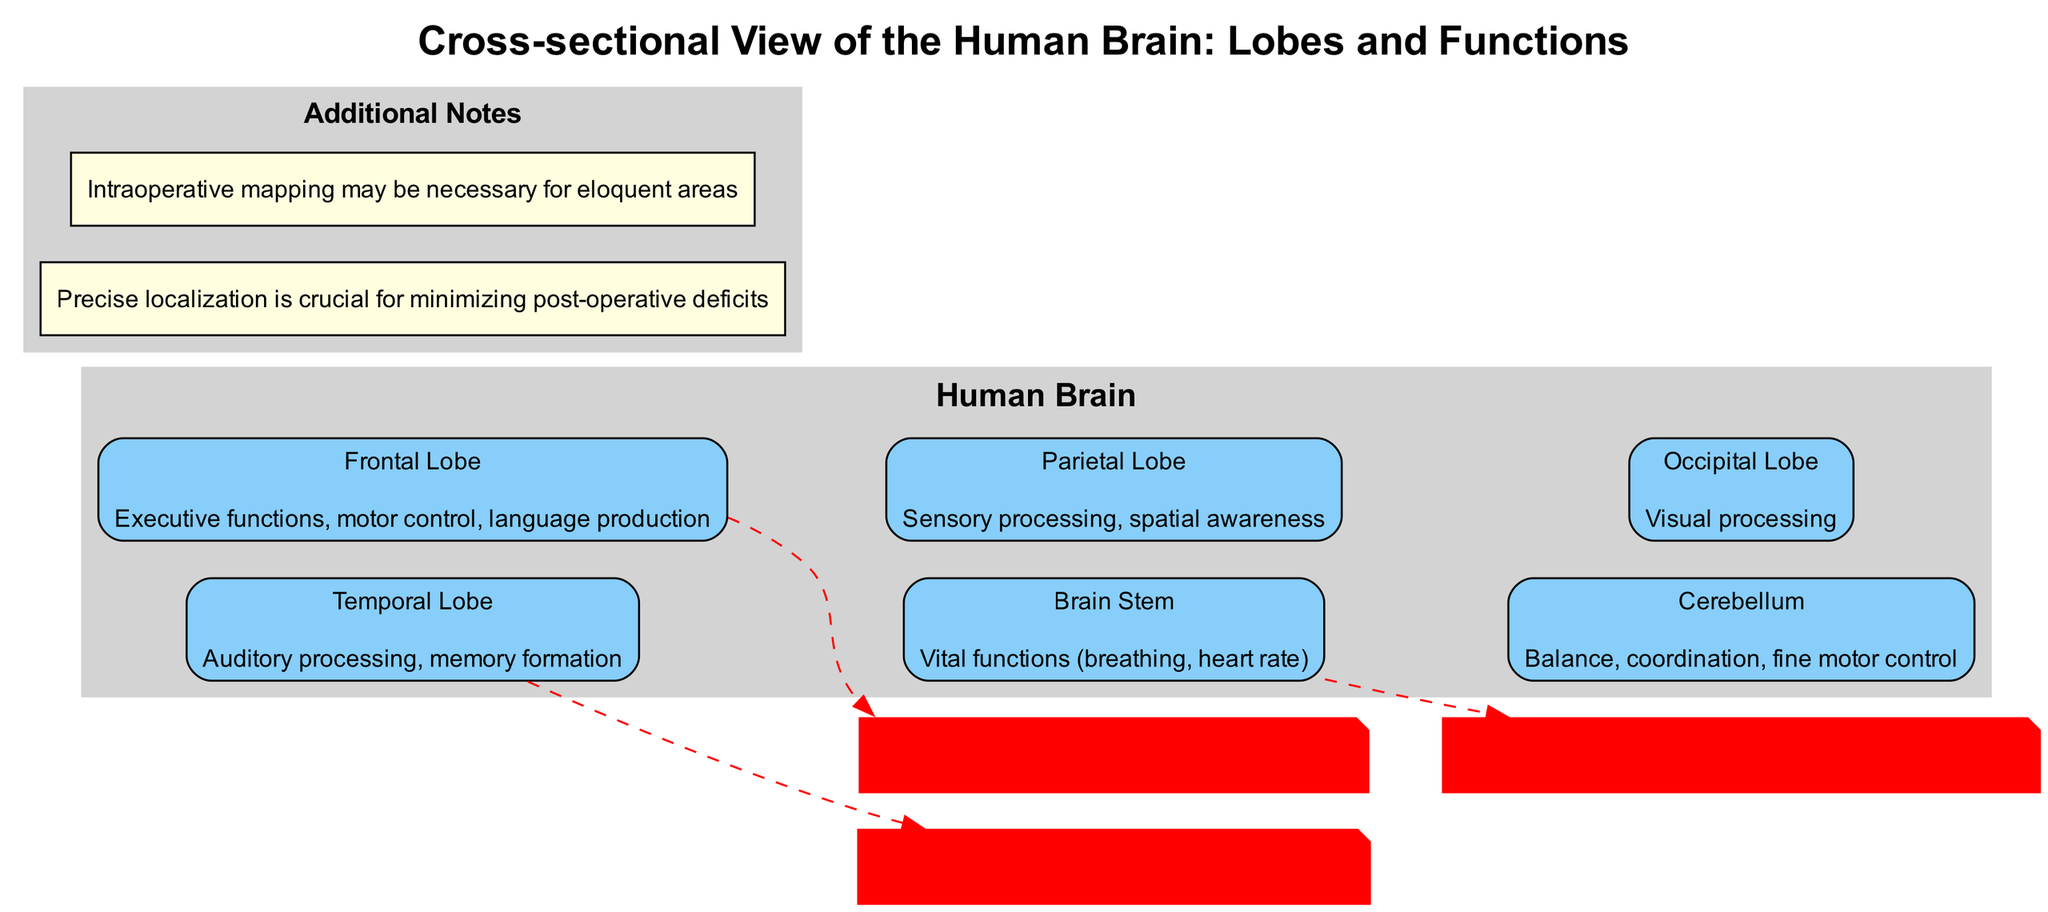What are the functions of the Frontal Lobe? The diagram indicates that the Frontal Lobe is responsible for executive functions, motor control, and language production. These functions are described directly on the node representing the Frontal Lobe, making it straightforward to extract this information.
Answer: Executive functions, motor control, language production How many lobes are highlighted in the diagram? Upon examining the diagram, there are a total of 5 distinct lobes displayed: Frontal Lobe, Parietal Lobe, Temporal Lobe, Occipital Lobe, and Cerebellum. By counting these nodes, the total can be determined accurately.
Answer: 5 What is the primary function associated with the Occipital Lobe? The diagram specifically states that the primary function of the Occipital Lobe is visual processing. This information can be found directly within the node labeled Occipital Lobe in the diagram.
Answer: Visual processing Which lobe is critical for language production? The diagram shows that the Frontal Lobe is associated with language production. To arrive at this answer, one must refer to the function next to the Frontal Lobe, which clearly mentions language production as part of its responsibilities.
Answer: Frontal Lobe What surgical consideration is associated with the Brain Stem? According to the diagram, the surgical consideration for the Brain Stem states that extreme caution is required due to its control of vital functions. This piece of information is linked directly beneath the Brain Stem node, allowing it to be easily identified.
Answer: Extreme caution required due to vital function control What additional step may be necessary when operating near eloquent areas? The diagram notes that intraoperative mapping may be necessary for eloquent areas. This information is separate from the main lobe functions and is highlighted as an important additional note, directly addressing concerns during surgery.
Answer: Intraoperative mapping What is the primary function of the Temporal Lobe? The diagram highlights that the Temporal Lobe is primarily responsible for auditory processing and memory formation. This can be found within the respective node for the Temporal Lobe, detailing its functions.
Answer: Auditory processing, memory formation What is the function of the Cerebellum? The Cerebellum is noted for its functions related to balance, coordination, and fine motor control. This information is directly provided in the diagram, making it easy to extract from the Cerebellum node.
Answer: Balance, coordination, fine motor control 